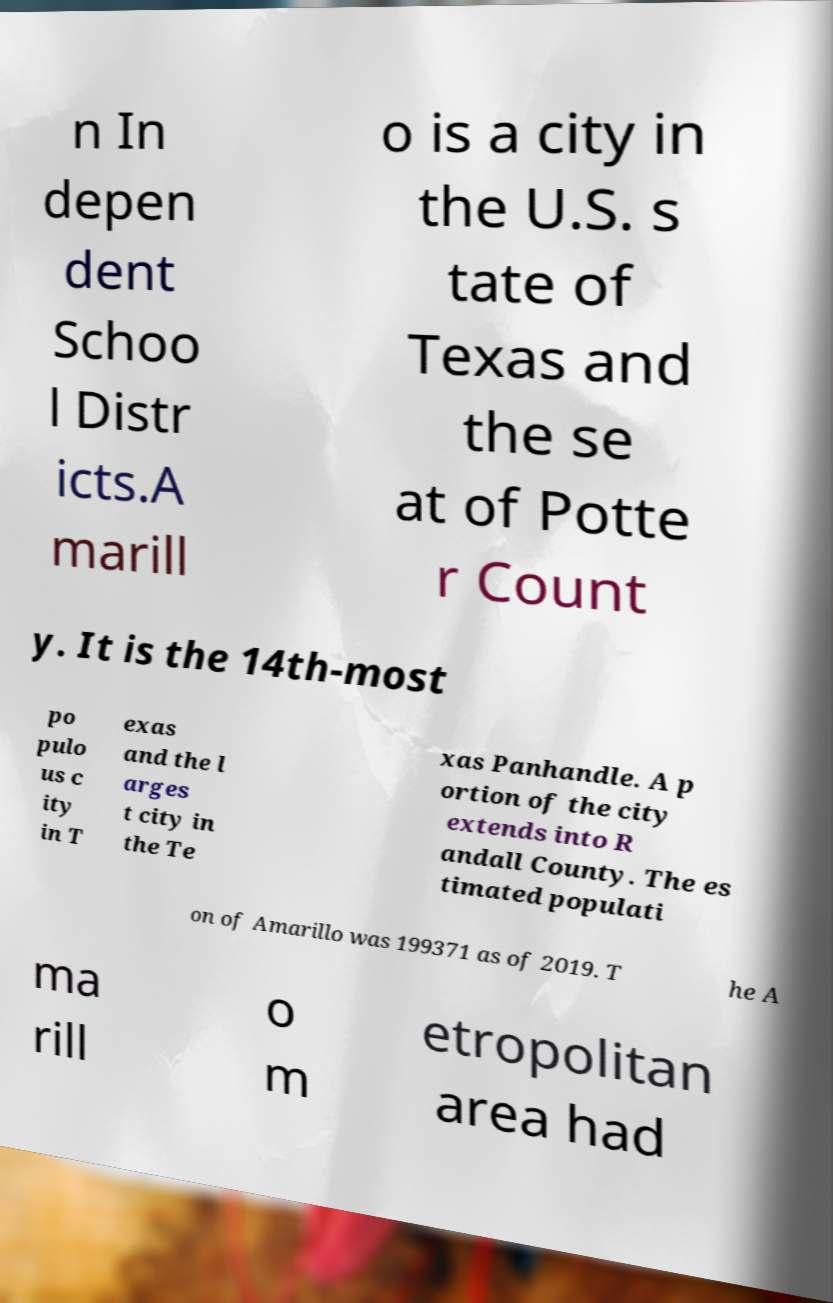I need the written content from this picture converted into text. Can you do that? n In depen dent Schoo l Distr icts.A marill o is a city in the U.S. s tate of Texas and the se at of Potte r Count y. It is the 14th-most po pulo us c ity in T exas and the l arges t city in the Te xas Panhandle. A p ortion of the city extends into R andall County. The es timated populati on of Amarillo was 199371 as of 2019. T he A ma rill o m etropolitan area had 